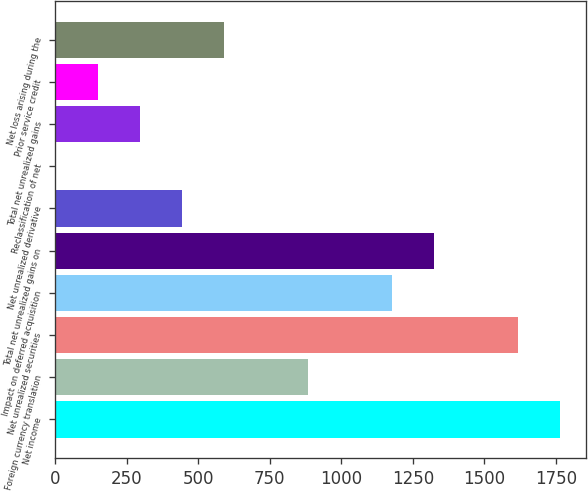Convert chart. <chart><loc_0><loc_0><loc_500><loc_500><bar_chart><fcel>Net income<fcel>Foreign currency translation<fcel>Net unrealized securities<fcel>Impact on deferred acquisition<fcel>Total net unrealized gains on<fcel>Net unrealized derivative<fcel>Reclassification of net<fcel>Total net unrealized gains<fcel>Prior service credit<fcel>Net loss arising during the<nl><fcel>1766.2<fcel>883.6<fcel>1619.1<fcel>1177.8<fcel>1324.9<fcel>442.3<fcel>1<fcel>295.2<fcel>148.1<fcel>589.4<nl></chart> 